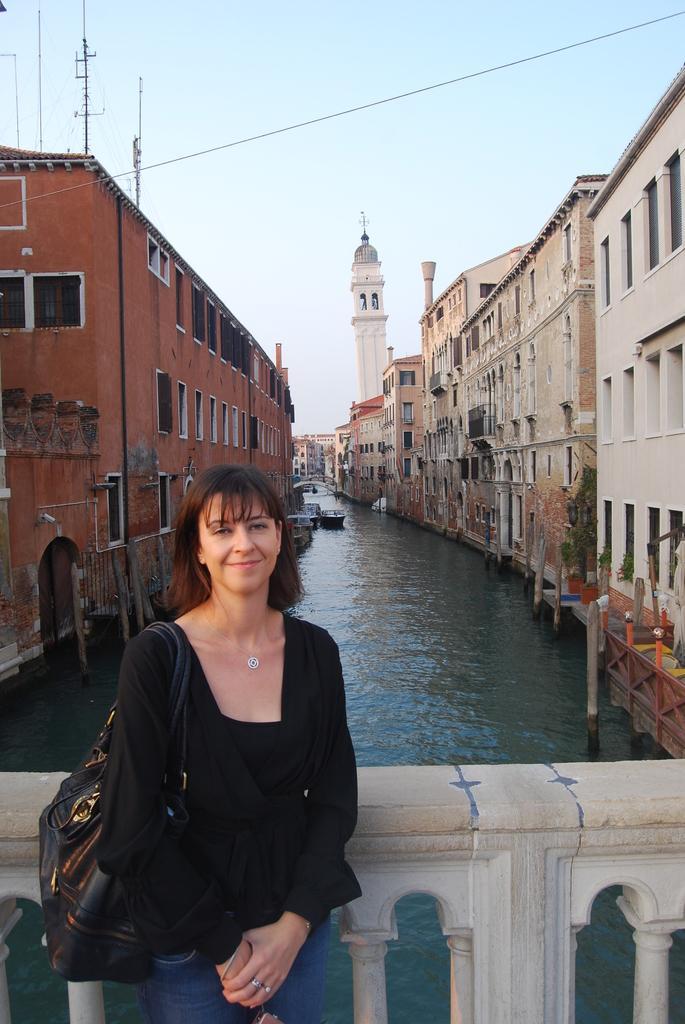In one or two sentences, can you explain what this image depicts? In this picture we can see the buildings, windows, wall, poles, boats, water, bridge. At the bottom of the image we can see a bridge. On the left side of the image we can see a lady is standing and carrying a bag. At the top of the image we can see the sky. 